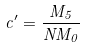<formula> <loc_0><loc_0><loc_500><loc_500>c ^ { \prime } = \frac { M _ { 5 } } { N M _ { 0 } }</formula> 